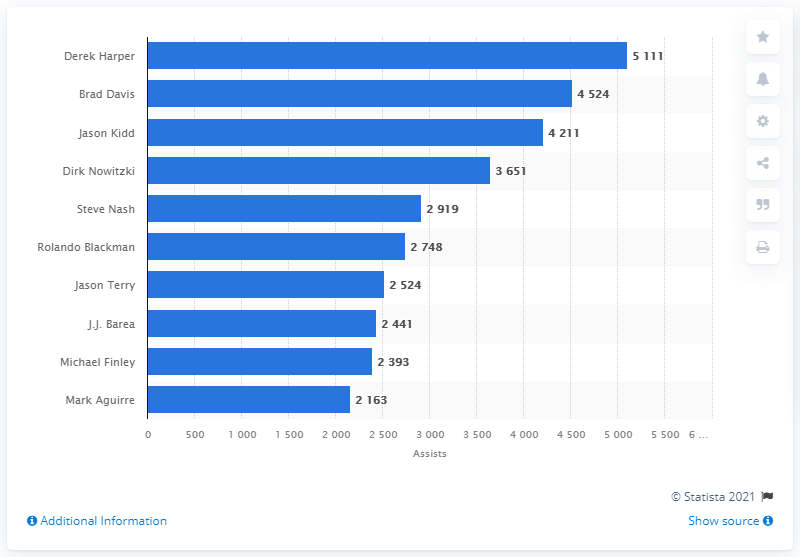Highlight a few significant elements in this photo. Derek Harper is the career assists leader of the Dallas Mavericks. 